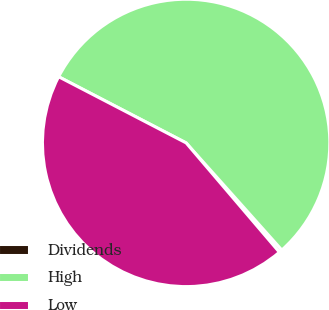Convert chart. <chart><loc_0><loc_0><loc_500><loc_500><pie_chart><fcel>Dividends<fcel>High<fcel>Low<nl><fcel>0.36%<fcel>55.78%<fcel>43.86%<nl></chart> 